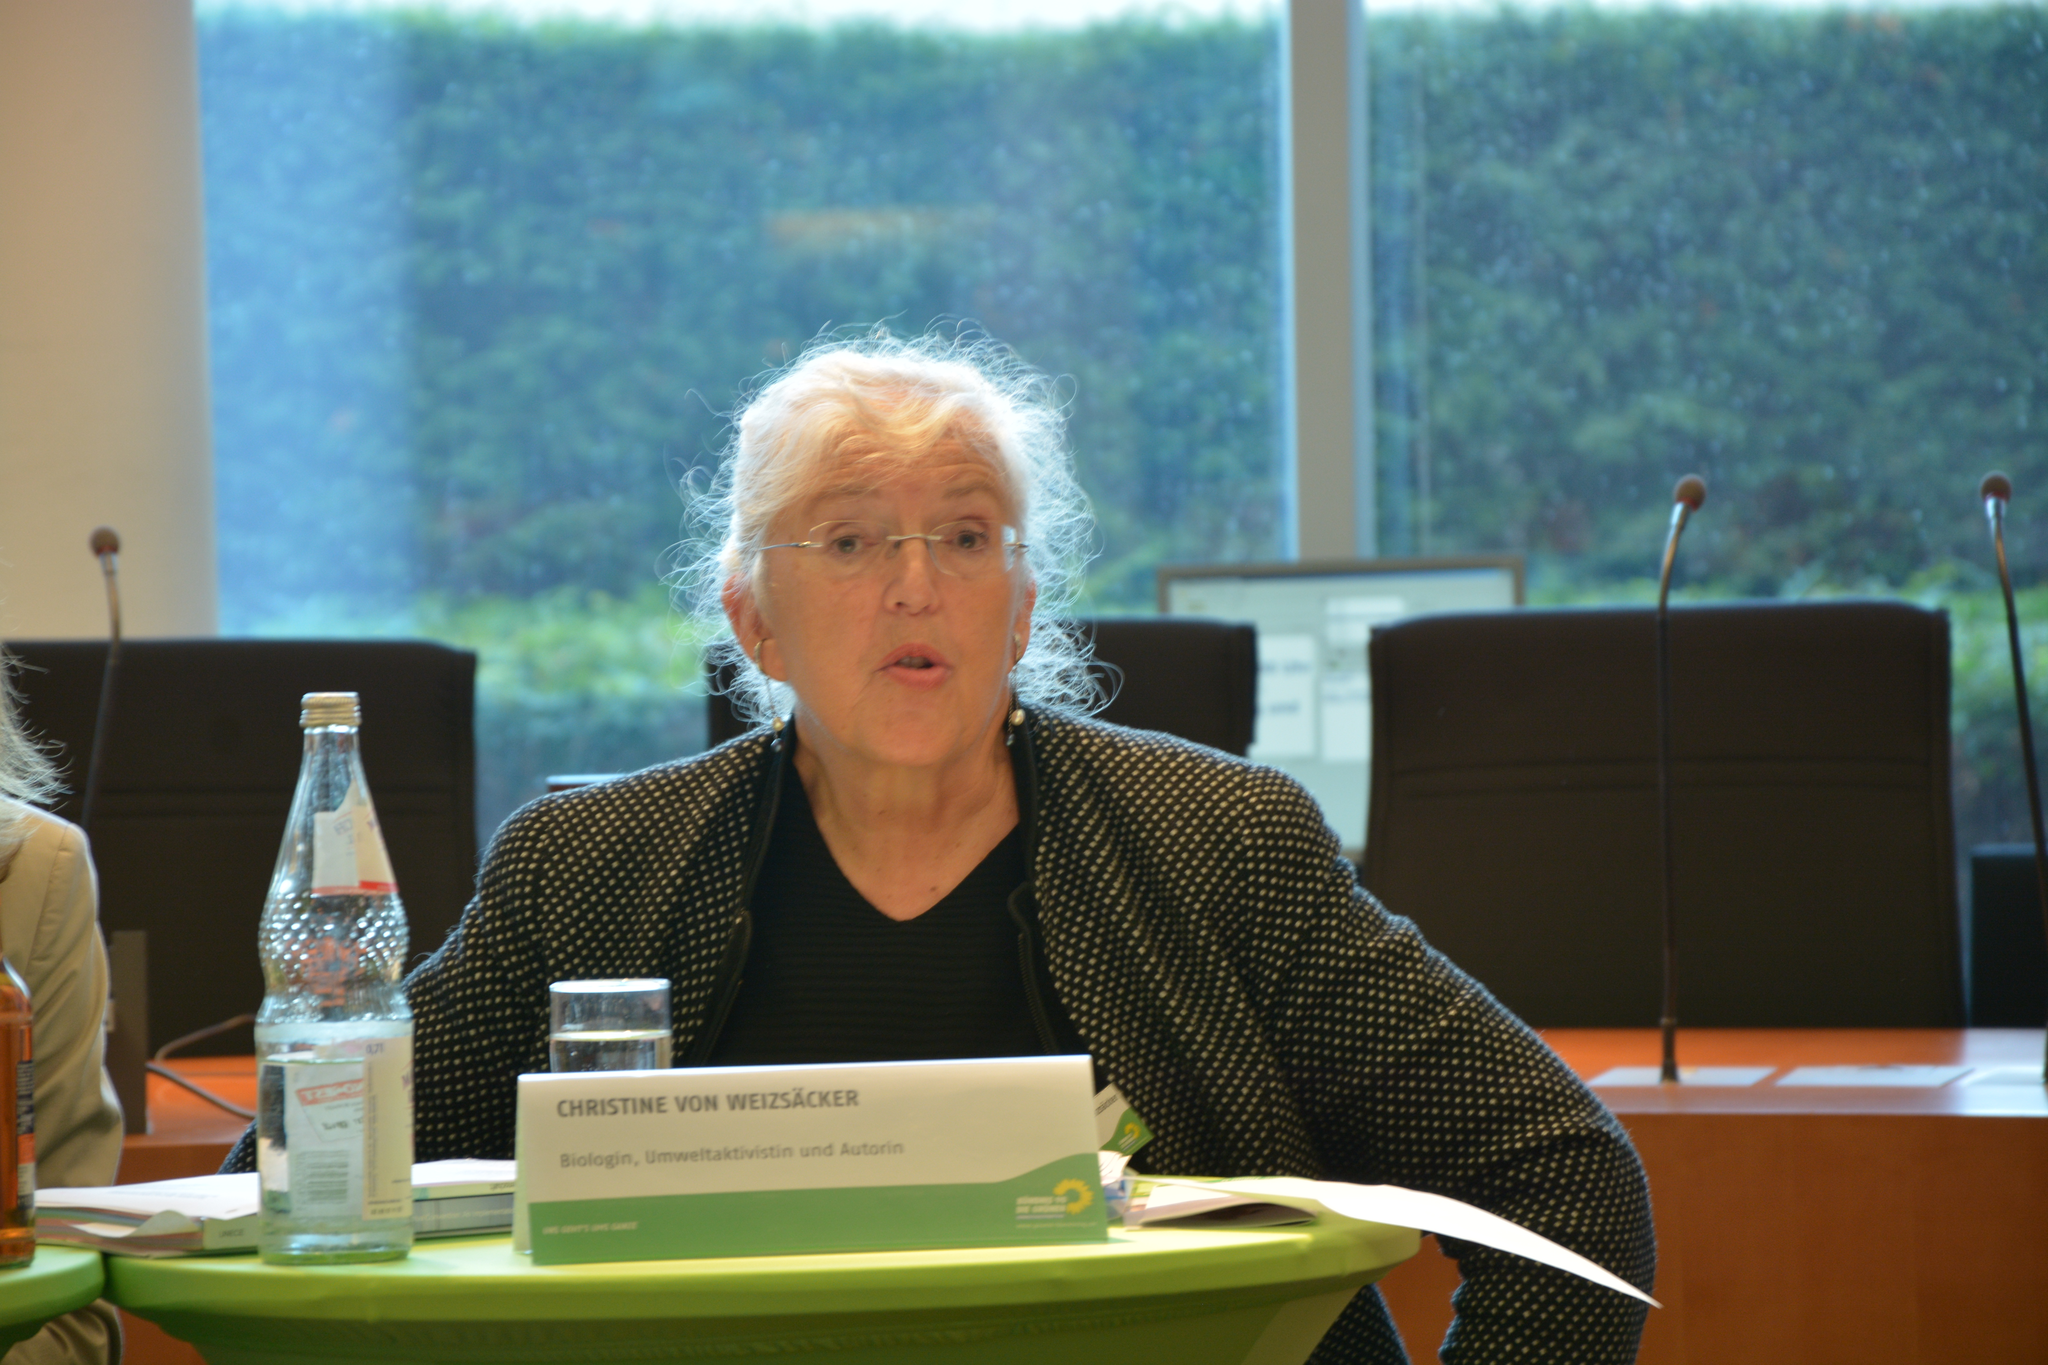<image>
Offer a succinct explanation of the picture presented. A woman sits behind a desk and a nameplate, which indicates her name is Christine. 